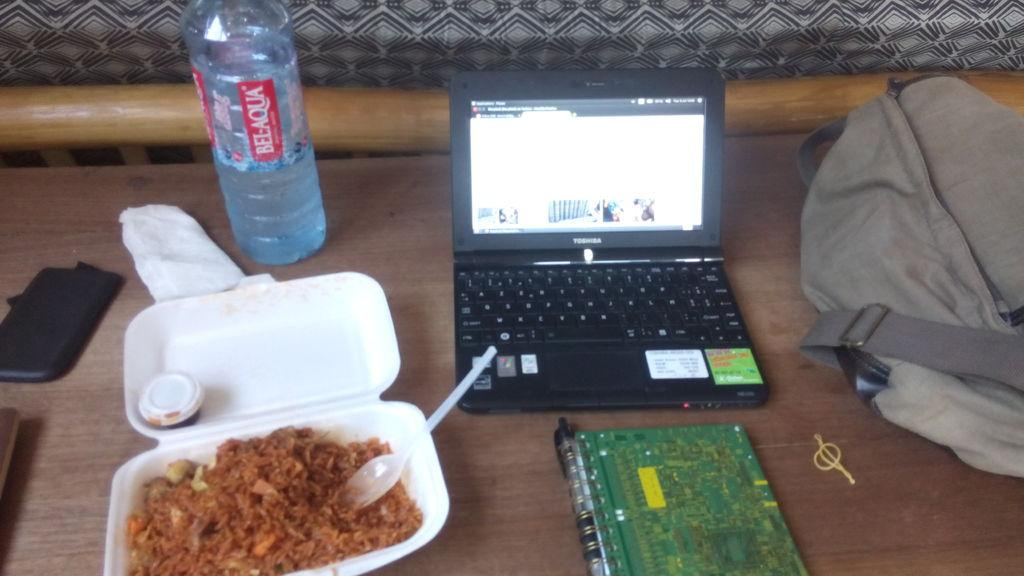<image>
Share a concise interpretation of the image provided. A container full of food next to a laptop and a bottle of water called Bel- Aqua. 